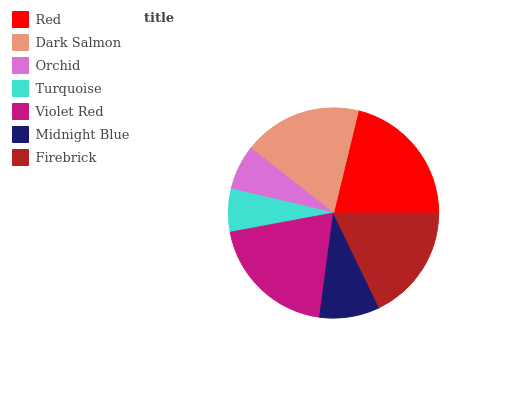Is Turquoise the minimum?
Answer yes or no. Yes. Is Red the maximum?
Answer yes or no. Yes. Is Dark Salmon the minimum?
Answer yes or no. No. Is Dark Salmon the maximum?
Answer yes or no. No. Is Red greater than Dark Salmon?
Answer yes or no. Yes. Is Dark Salmon less than Red?
Answer yes or no. Yes. Is Dark Salmon greater than Red?
Answer yes or no. No. Is Red less than Dark Salmon?
Answer yes or no. No. Is Firebrick the high median?
Answer yes or no. Yes. Is Firebrick the low median?
Answer yes or no. Yes. Is Midnight Blue the high median?
Answer yes or no. No. Is Violet Red the low median?
Answer yes or no. No. 